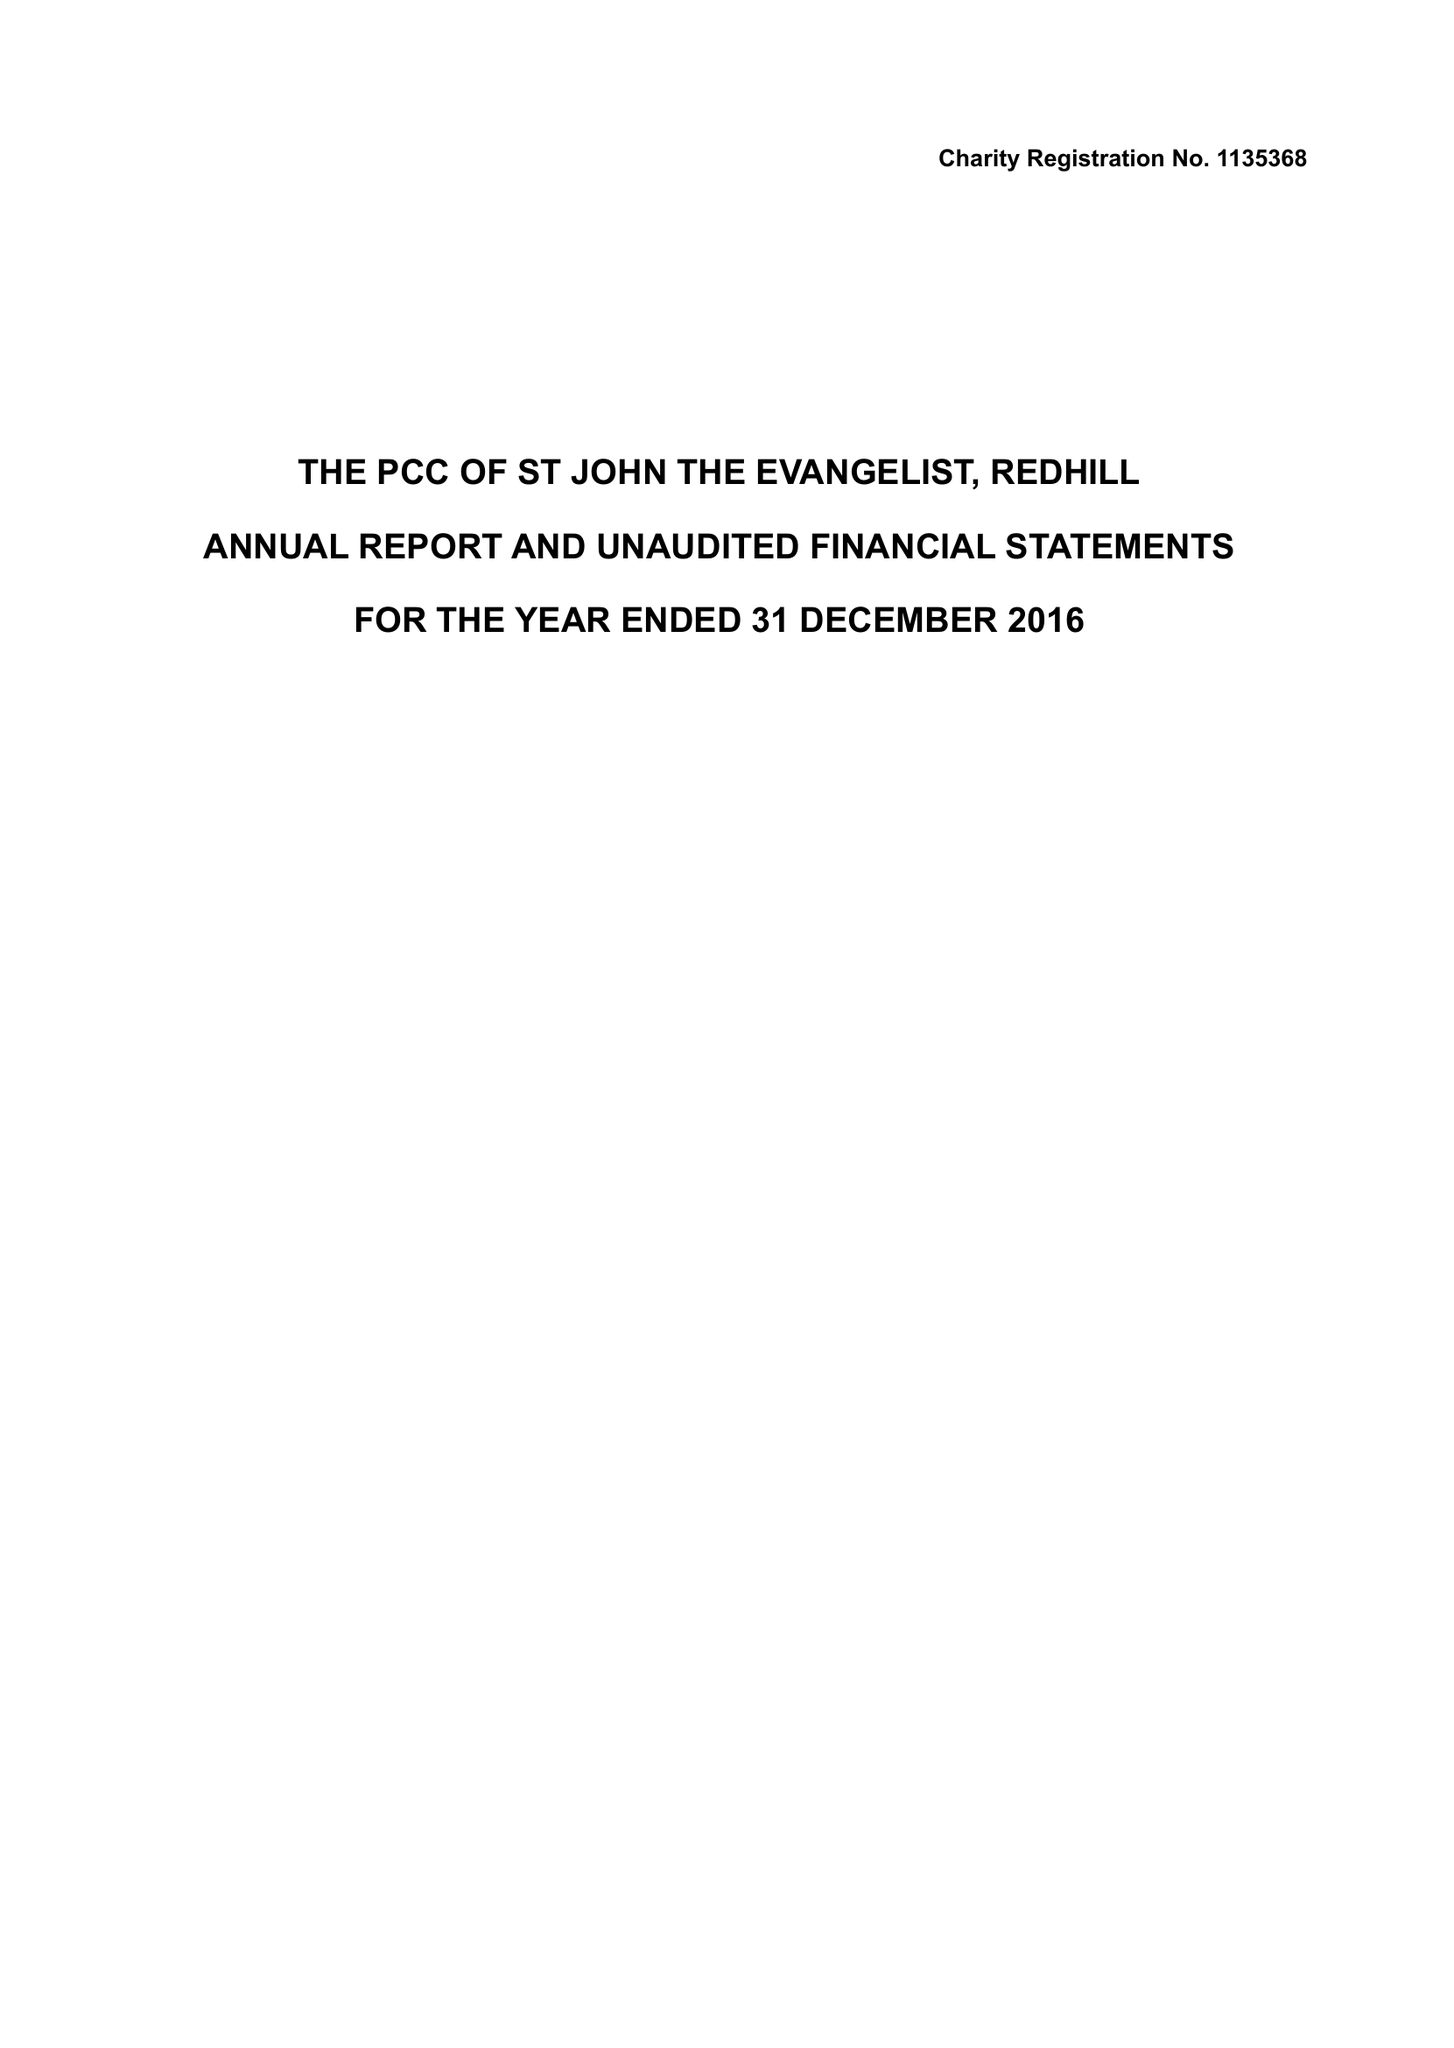What is the value for the income_annually_in_british_pounds?
Answer the question using a single word or phrase. 339478.00 